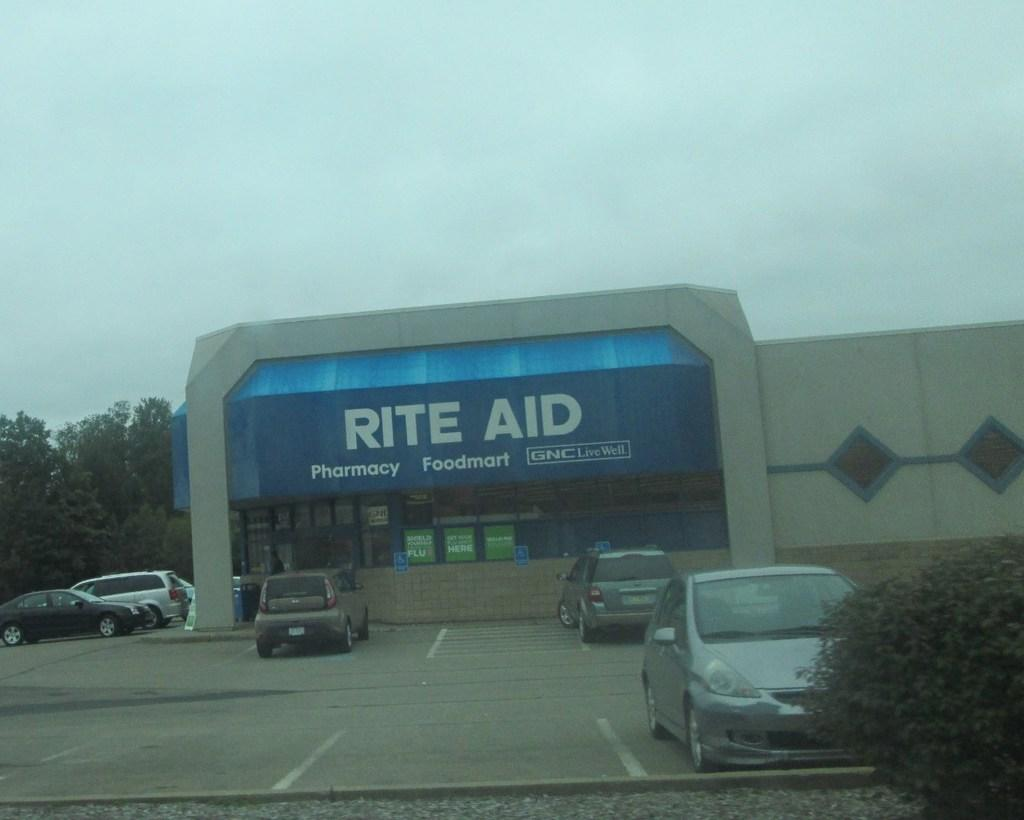What type of structure is present in the image? There is a building in the image. Are there any vehicles near the building? Yes, there are cars parked near the building. What else can be seen in the image besides the building and cars? There are trees in the image. What is written on the building? There is a name board on the building. How would you describe the weather in the image? The sky is cloudy in the image. How many eyes can be seen on the trees in the image? Trees do not have eyes, so there are no eyes visible on the trees in the image. 